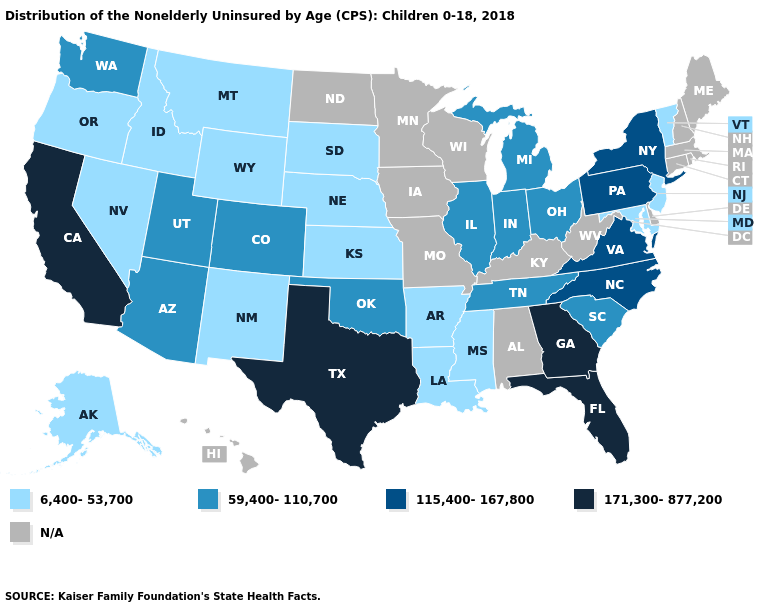Name the states that have a value in the range 115,400-167,800?
Answer briefly. New York, North Carolina, Pennsylvania, Virginia. Which states have the highest value in the USA?
Be succinct. California, Florida, Georgia, Texas. Which states have the lowest value in the USA?
Concise answer only. Alaska, Arkansas, Idaho, Kansas, Louisiana, Maryland, Mississippi, Montana, Nebraska, Nevada, New Jersey, New Mexico, Oregon, South Dakota, Vermont, Wyoming. Which states have the lowest value in the South?
Concise answer only. Arkansas, Louisiana, Maryland, Mississippi. What is the value of Connecticut?
Short answer required. N/A. What is the highest value in the West ?
Concise answer only. 171,300-877,200. Among the states that border New York , does New Jersey have the highest value?
Quick response, please. No. Name the states that have a value in the range 115,400-167,800?
Answer briefly. New York, North Carolina, Pennsylvania, Virginia. What is the value of Montana?
Short answer required. 6,400-53,700. Which states have the lowest value in the USA?
Quick response, please. Alaska, Arkansas, Idaho, Kansas, Louisiana, Maryland, Mississippi, Montana, Nebraska, Nevada, New Jersey, New Mexico, Oregon, South Dakota, Vermont, Wyoming. What is the lowest value in the South?
Be succinct. 6,400-53,700. What is the highest value in the USA?
Quick response, please. 171,300-877,200. Name the states that have a value in the range 59,400-110,700?
Give a very brief answer. Arizona, Colorado, Illinois, Indiana, Michigan, Ohio, Oklahoma, South Carolina, Tennessee, Utah, Washington. 